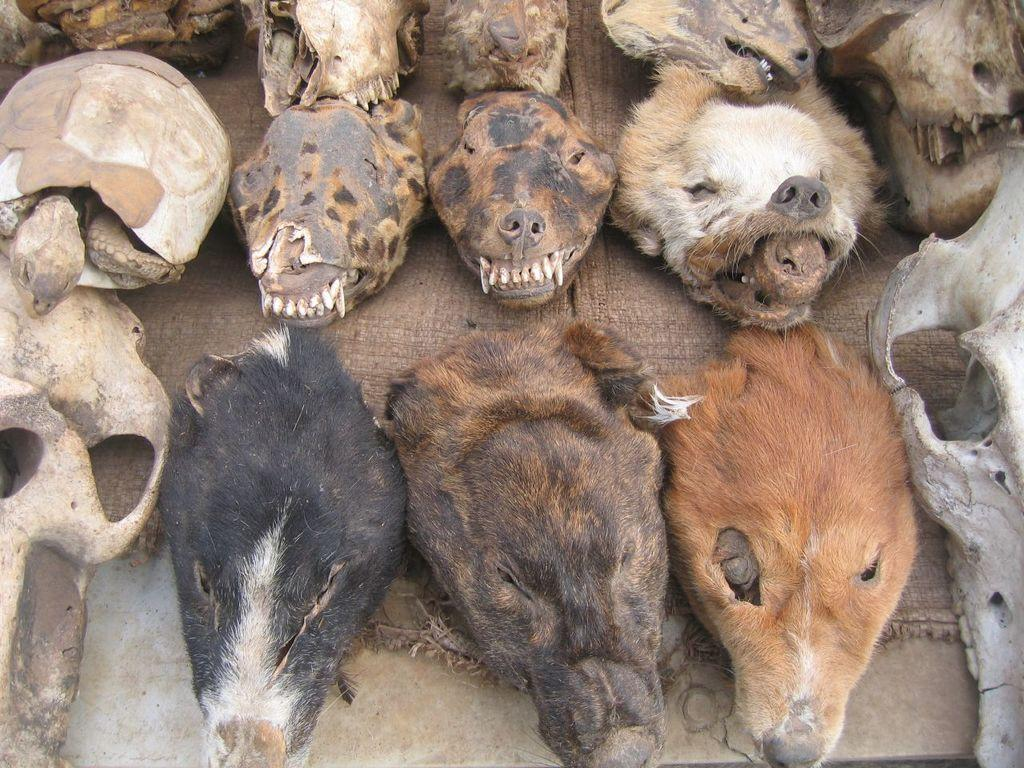What types of animal heads can be seen in the image? There are different types of animal heads visible in the image. What is located at the bottom of the image? There is a walkway at the bottom of the image. What grade does the receipt for the sand in the image receive? There is no sand, receipt, or grade present in the image. 